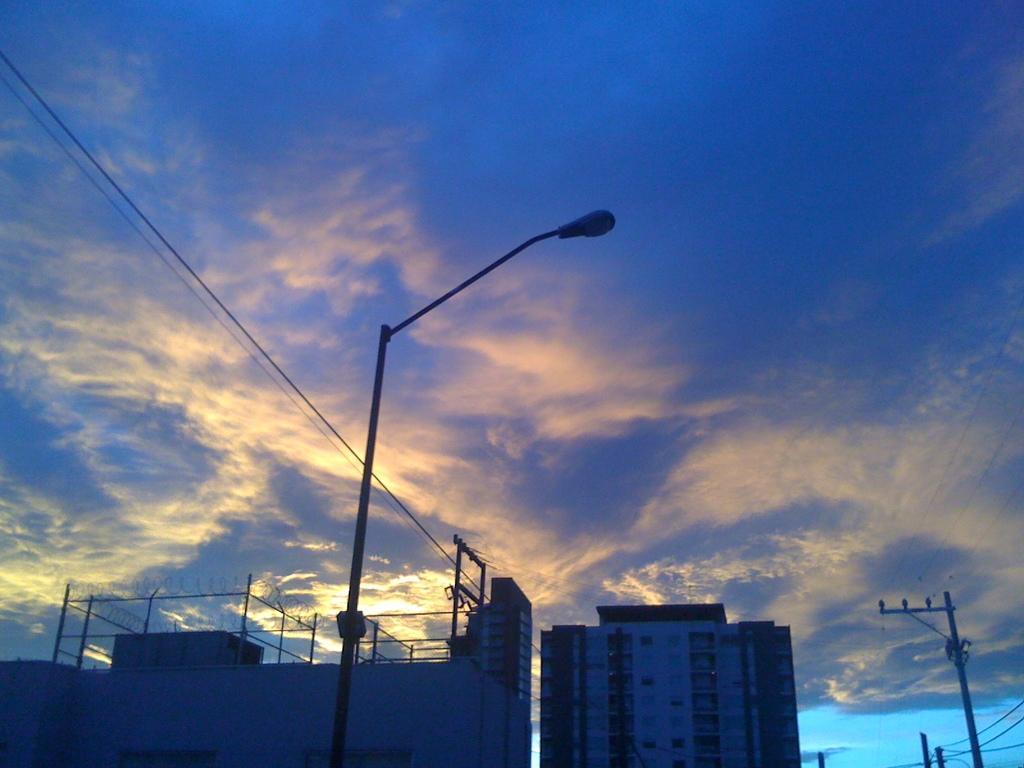Please provide a concise description of this image. At the bottom of the image we can see buildings and there are poles. In the background there are wires and sky. 